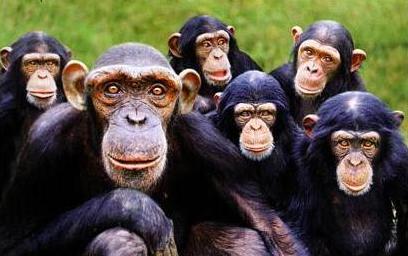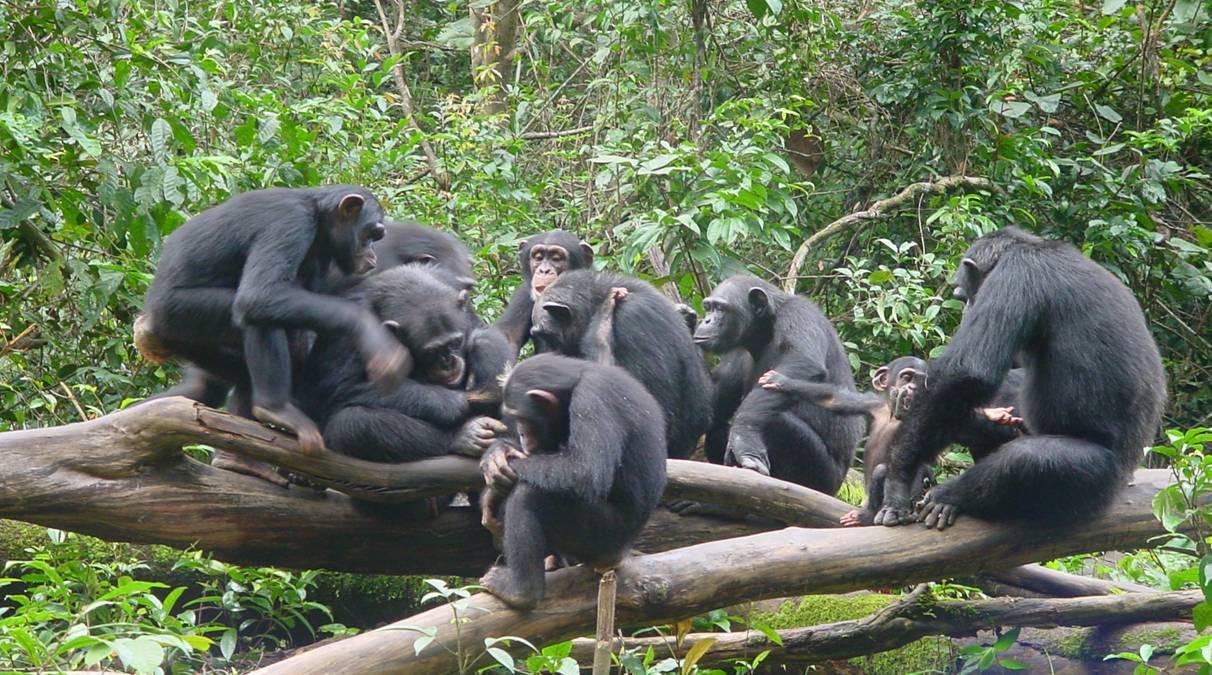The first image is the image on the left, the second image is the image on the right. Evaluate the accuracy of this statement regarding the images: "Left image contains no more than four chimps, including a close trio.". Is it true? Answer yes or no. No. 